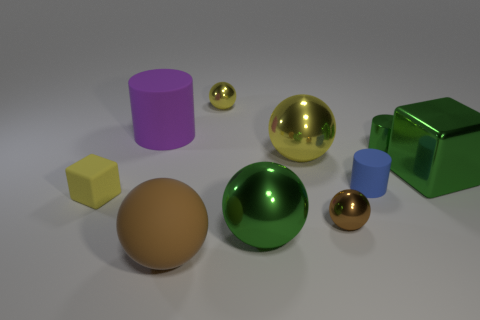Subtract all metal cylinders. How many cylinders are left? 2 Subtract all cylinders. How many objects are left? 7 Subtract all green blocks. How many blocks are left? 1 Subtract all cyan cylinders. How many gray balls are left? 0 Subtract all small brown things. Subtract all big shiny things. How many objects are left? 6 Add 5 big purple matte things. How many big purple matte things are left? 6 Add 7 yellow rubber cylinders. How many yellow rubber cylinders exist? 7 Subtract 0 gray balls. How many objects are left? 10 Subtract 2 spheres. How many spheres are left? 3 Subtract all gray cylinders. Subtract all cyan spheres. How many cylinders are left? 3 